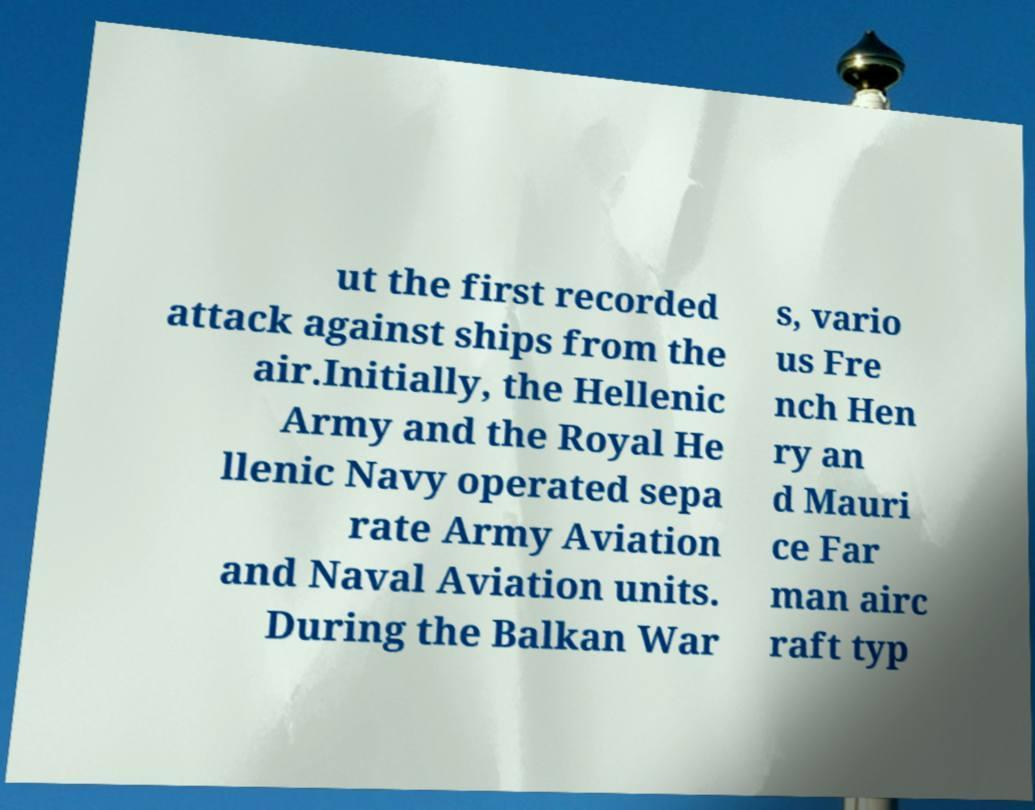Can you accurately transcribe the text from the provided image for me? ut the first recorded attack against ships from the air.Initially, the Hellenic Army and the Royal He llenic Navy operated sepa rate Army Aviation and Naval Aviation units. During the Balkan War s, vario us Fre nch Hen ry an d Mauri ce Far man airc raft typ 